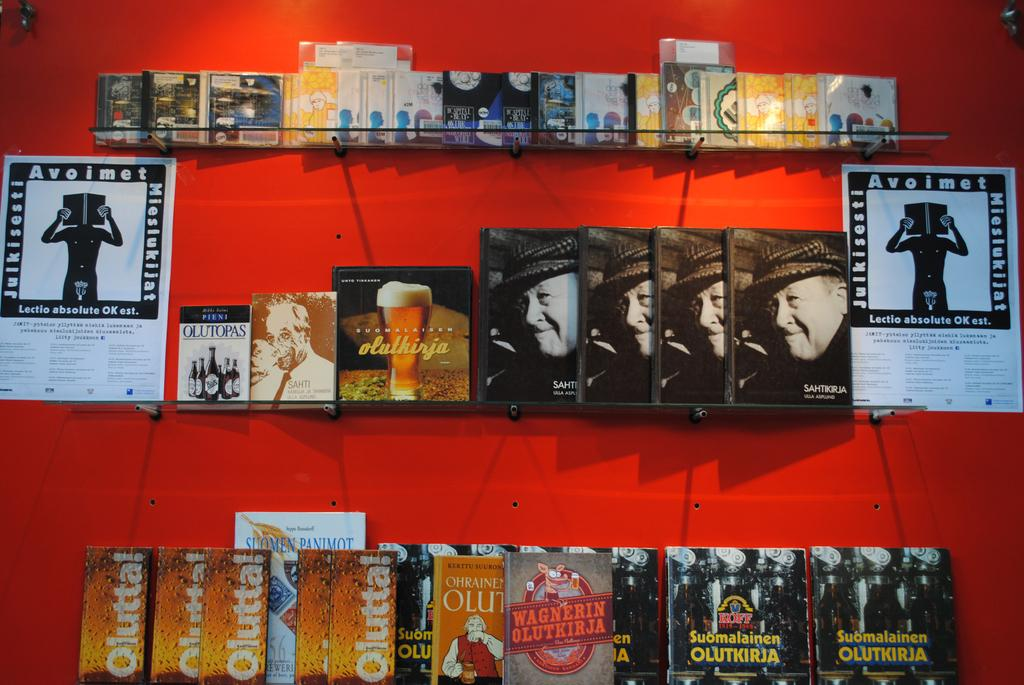What objects are on the glass shelves in the image? There are books on the glass shelves in the image. What can be seen on the wall in the image? There are posts on the wall in the image. What type of bell can be heard ringing in the image? There is no bell present in the image, and therefore no such sound can be heard. What rhythm is the music following in the image? There is no music or rhythm present in the image. 